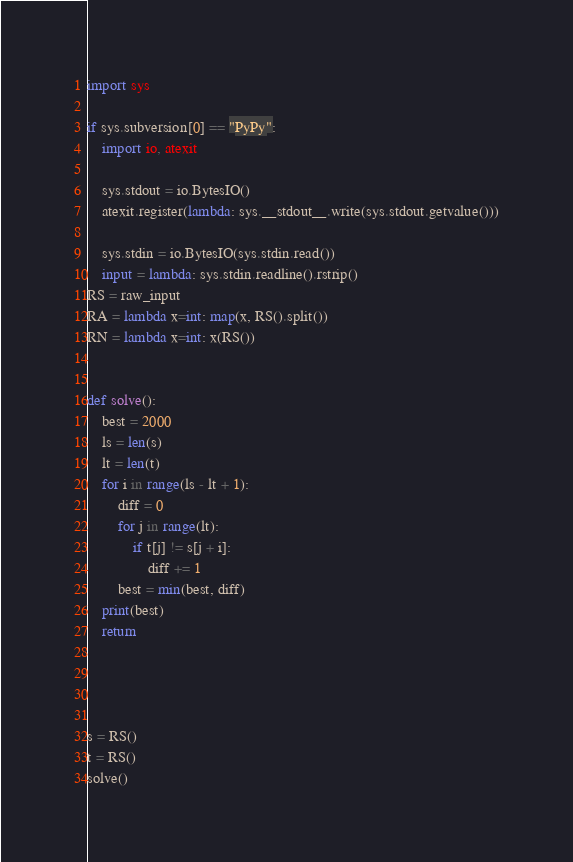<code> <loc_0><loc_0><loc_500><loc_500><_Python_>import sys

if sys.subversion[0] == "PyPy":
    import io, atexit

    sys.stdout = io.BytesIO()
    atexit.register(lambda: sys.__stdout__.write(sys.stdout.getvalue()))

    sys.stdin = io.BytesIO(sys.stdin.read())
    input = lambda: sys.stdin.readline().rstrip()
RS = raw_input
RA = lambda x=int: map(x, RS().split())
RN = lambda x=int: x(RS())


def solve():
    best = 2000
    ls = len(s)
    lt = len(t)
    for i in range(ls - lt + 1):
        diff = 0
        for j in range(lt):
            if t[j] != s[j + i]:
                diff += 1
        best = min(best, diff)
    print(best)
    return




s = RS()
t = RS()
solve()
</code> 